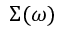<formula> <loc_0><loc_0><loc_500><loc_500>\Sigma ( \omega )</formula> 